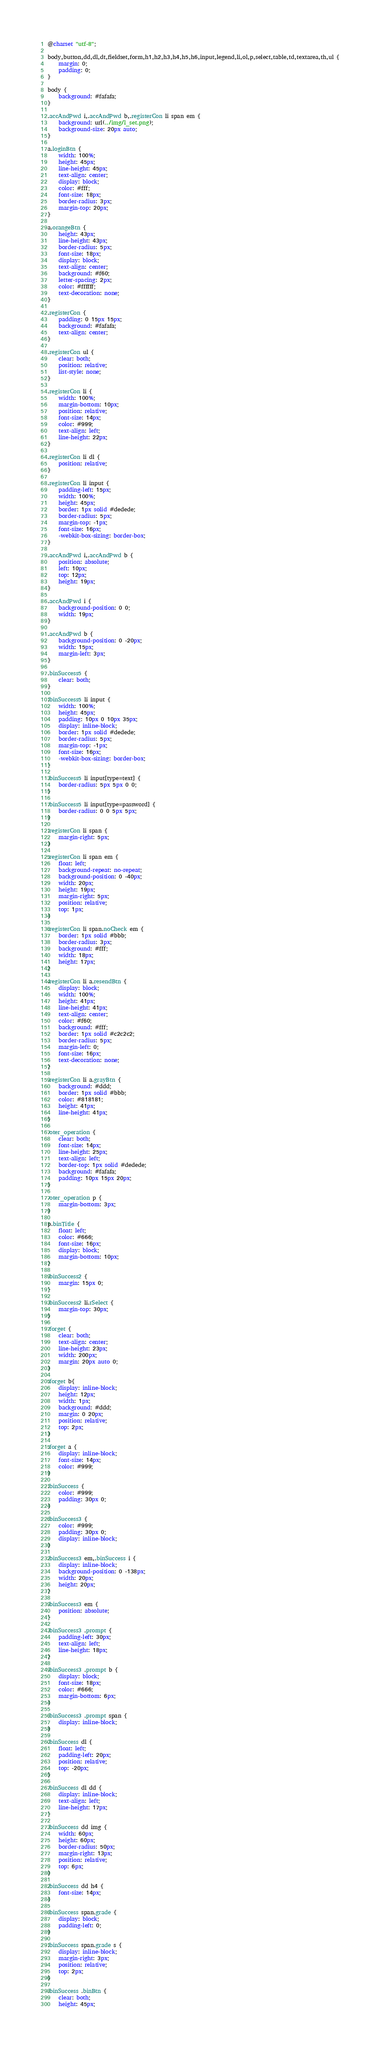<code> <loc_0><loc_0><loc_500><loc_500><_CSS_>@charset "utf-8";

body,button,dd,dl,dt,fieldset,form,h1,h2,h3,h4,h5,h6,input,legend,li,ol,p,select,table,td,textarea,th,ul {
    margin: 0;
    padding: 0;
}

body {
    background: #fafafa;
}

.accAndPwd i,.accAndPwd b,.registerCon li span em {
    background: url(../img/l_set.png);
    background-size: 20px auto;
}

a.loginBtn {
    width: 100%;
    height: 45px;
    line-height: 45px;
    text-align: center;
    display: block;
    color: #fff;
    font-size: 18px;
    border-radius: 3px;
    margin-top: 20px;
}

a.orangeBtn {
    height: 43px;
    line-height: 43px;
    border-radius: 5px;
    font-size: 18px;
    display: block;
    text-align: center;
    background: #f60;
    letter-spacing: 2px;
    color: #ffffff;
    text-decoration: none;
}

.registerCon {
    padding: 0 15px 15px;
    background: #fafafa;
    text-align: center;
}

.registerCon ul {
    clear: both;
    position: relative;
    list-style: none;
}

.registerCon li {
    width: 100%;
    margin-bottom: 10px;
    position: relative;
    font-size: 14px;
    color: #999;
    text-align: left;
    line-height: 22px;
}

.registerCon li dl {
    position: relative;
}

.registerCon li input {
    padding-left: 15px;
    width: 100%;
    height: 45px;
    border: 1px solid #dedede;
    border-radius: 5px;
    margin-top: -1px;
    font-size: 16px;
    -webkit-box-sizing: border-box;
}

.accAndPwd i,.accAndPwd b {
    position: absolute;
    left: 10px;
    top: 12px;
    height: 19px;
}

.accAndPwd i {
    background-position: 0 0;
    width: 19px;
}

.accAndPwd b {
    background-position: 0 -20px;
    width: 15px;
    margin-left: 3px;
}

.binSuccess5 {
    clear: both;
}

.binSuccess5 li input {
    width: 100%;
    height: 45px;
    padding: 10px 0 10px 35px;
    display: inline-block;
    border: 1px solid #dedede;
    border-radius: 5px;
    margin-top: -1px;
    font-size: 16px;
    -webkit-box-sizing: border-box;
}

.binSuccess5 li input[type=text] {
    border-radius: 5px 5px 0 0;
}

.binSuccess5 li input[type=password] {
    border-radius: 0 0 5px 5px;
}

.registerCon li span {
    margin-right: 5px;
}

.registerCon li span em {
    float: left;
    background-repeat: no-repeat;
    background-position: 0 -40px;
    width: 20px;
    height: 19px;
    margin-right: 5px;
    position: relative;
    top: 1px;
}

.registerCon li span.noCheck em {
    border: 1px solid #bbb;
    border-radius: 3px;
    background: #fff;
    width: 18px;
    height: 17px;
}

.registerCon li a.resendBtn {
    display: block;
    width: 100%;
    height: 41px;
    line-height: 41px;
    text-align: center;
    color: #f60;
    background: #fff;
    border: 1px solid #c2c2c2;
    border-radius: 5px;
    margin-left: 0;
    font-size: 16px;
    text-decoration: none;
}

.registerCon li a.grayBtn {
    background: #ddd;
    border: 1px solid #bbb;
    color: #818181;
    height: 41px;
    line-height: 41px;
}

.oter_operation {
    clear: both;
    font-size: 14px;
    line-height: 25px;
    text-align: left;
    border-top: 1px solid #dedede;
    background: #fafafa;
    padding: 10px 15px 20px;
}

.oter_operation p {
    margin-bottom: 3px;
}

p.binTitle {
    float: left;
    color: #666;
    font-size: 16px;
    display: block;
    margin-bottom: 10px;
}

.binSuccess2 {
    margin: 15px 0;
}

.binSuccess2 li.rSelect {
    margin-top: 30px;
}

.forget {
    clear: both;
    text-align: center;
    line-height: 23px;
    width: 200px;
    margin: 20px auto 0;
}

.forget b{
    display: inline-block;
    height: 12px;
    width: 1px;
    background: #ddd;
    margin: 0 20px;
    position: relative;
    top: 2px;
}

.forget a {
    display: inline-block;
    font-size: 14px;
    color: #999;
}

.binSuccess {
    color: #999;
    padding: 30px 0;
}

.binSuccess3 {
    color: #999;
    padding: 30px 0;
    display: inline-block;
}

.binSuccess3 em,.binSuccess i {
    display: inline-block;
    background-position: 0 -138px;
    width: 20px;
    height: 20px;
}

.binSuccess3 em {
    position: absolute;
}

.binSuccess3 .prompt {
    padding-left: 30px;
    text-align: left;
    line-height: 18px;
}

.binSuccess3 .prompt b {
    display: block;
    font-size: 18px;
    color: #666;
    margin-bottom: 6px;
}

.binSuccess3 .prompt span {
    display: inline-block;
}

.binSuccess dl {
    float: left;
    padding-left: 20px;
    position: relative;
    top: -20px;
}

.binSuccess dl dd {
    display: inline-block;
    text-align: left;
    line-height: 17px;
}

.binSuccess dd img {
    width: 60px;
    height: 60px;
    border-radius: 50px;
    margin-right: 13px;
    position: relative;
    top: 6px;
}

.binSuccess dd h4 {
    font-size: 14px;
}

.binSuccess span.grade {
    display: block;
    padding-left: 0;
}

.binSuccess span.grade s {
    display: inline-block;
    margin-right: 3px;
    position: relative;
    top: 2px;
}

.binSuccess .binBtn {
    clear: both;
    height: 45px;</code> 